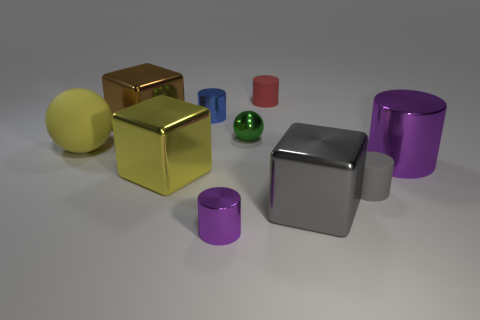There is a object in front of the big gray cube; what is its material? The object in front of the large gray cube appears to have a shiny surface reflecting the environment, which suggests that it's likely made of a polished metal, possibly stainless steel. 